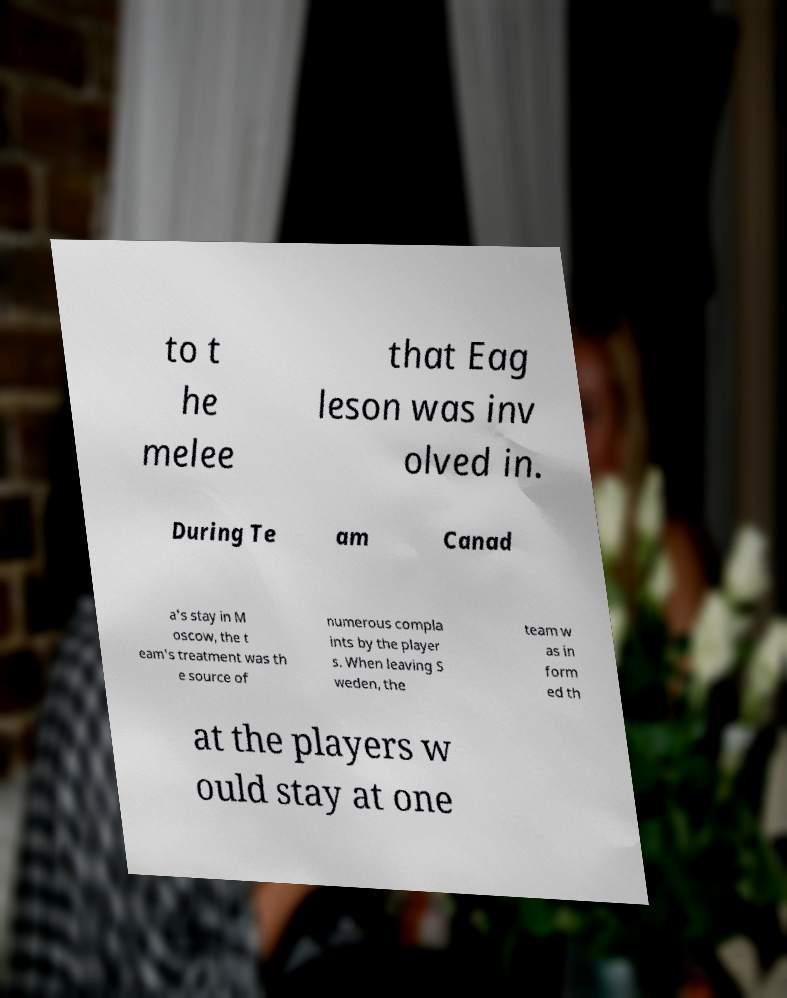Please identify and transcribe the text found in this image. to t he melee that Eag leson was inv olved in. During Te am Canad a's stay in M oscow, the t eam's treatment was th e source of numerous compla ints by the player s. When leaving S weden, the team w as in form ed th at the players w ould stay at one 